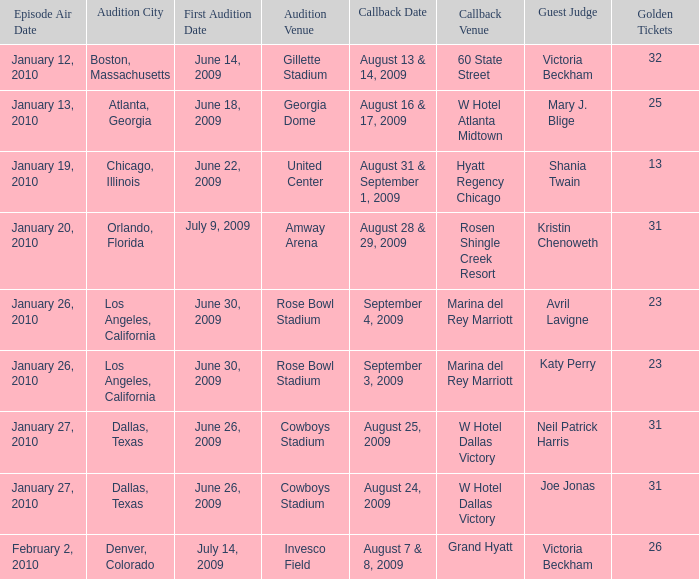Name the total number of golden tickets being rosen shingle creek resort 1.0. 